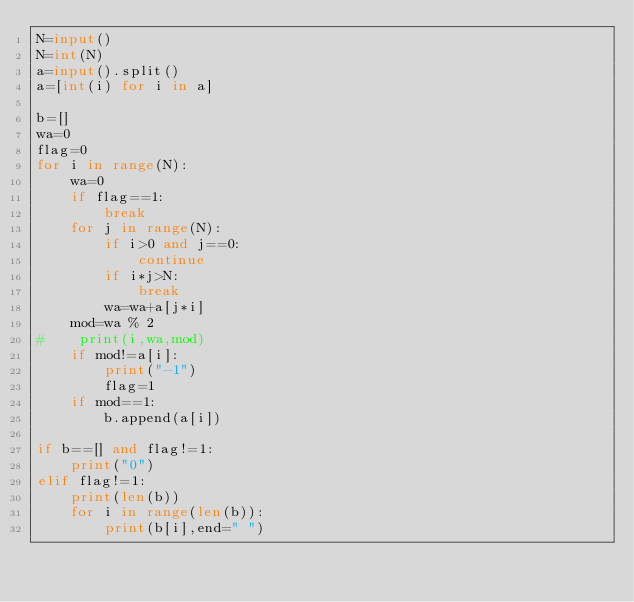<code> <loc_0><loc_0><loc_500><loc_500><_Python_>N=input()
N=int(N)
a=input().split()
a=[int(i) for i in a]

b=[]
wa=0
flag=0
for i in range(N):
    wa=0
    if flag==1:
        break
    for j in range(N):
        if i>0 and j==0:
            continue
        if i*j>N:
            break
        wa=wa+a[j*i]
    mod=wa % 2
#    print(i,wa,mod)
    if mod!=a[i]:
        print("-1")
        flag=1
    if mod==1:
        b.append(a[i])

if b==[] and flag!=1:
    print("0")
elif flag!=1:
    print(len(b))
    for i in range(len(b)):
        print(b[i],end=" ")    
</code> 